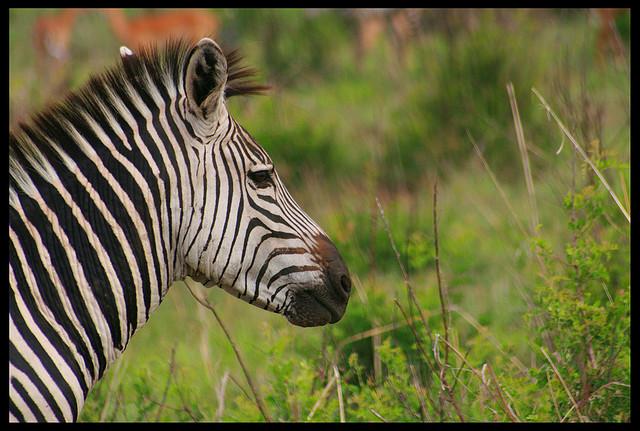Is the zebra eating the plants?
Concise answer only. No. What color is this picture?
Answer briefly. Black, white and green. Is the zebra thinking?
Keep it brief. Yes. Is the zebra in its natural habitat?
Quick response, please. Yes. Is the grass green?
Be succinct. Yes. What is it doing?
Short answer required. Standing. Is this a donkey?
Short answer required. No. 